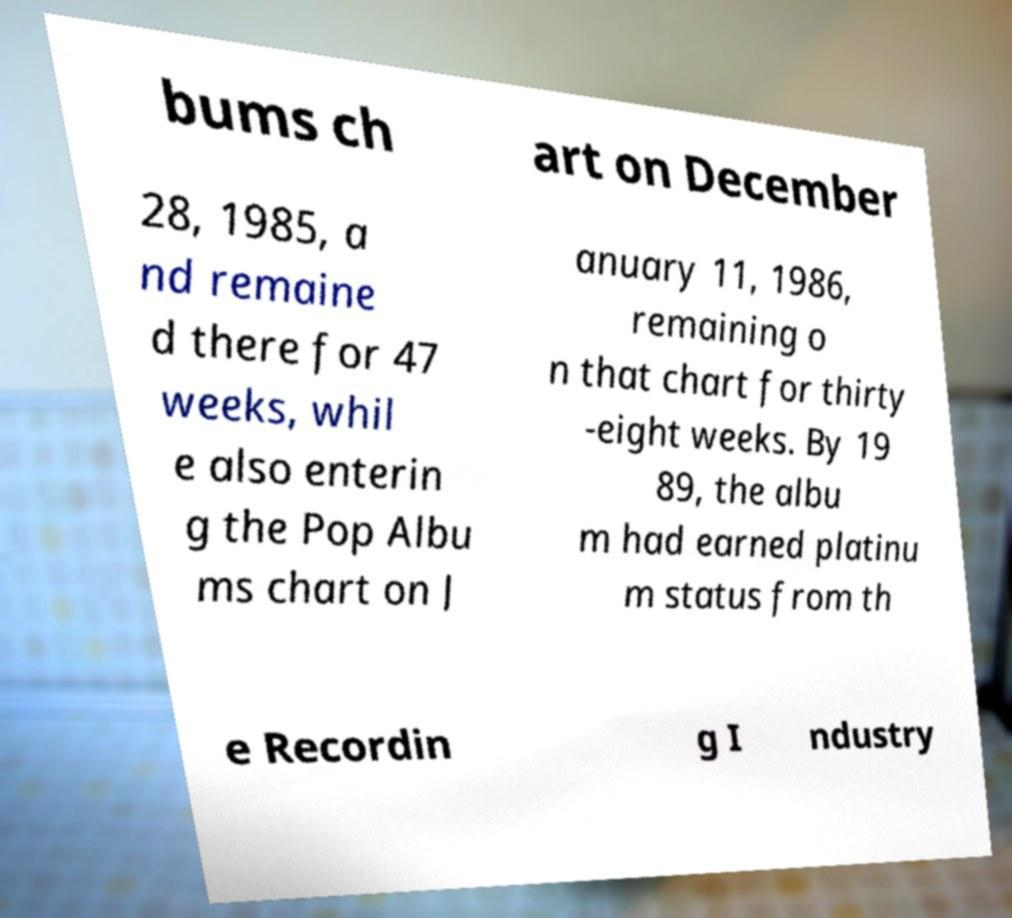Can you read and provide the text displayed in the image?This photo seems to have some interesting text. Can you extract and type it out for me? bums ch art on December 28, 1985, a nd remaine d there for 47 weeks, whil e also enterin g the Pop Albu ms chart on J anuary 11, 1986, remaining o n that chart for thirty -eight weeks. By 19 89, the albu m had earned platinu m status from th e Recordin g I ndustry 